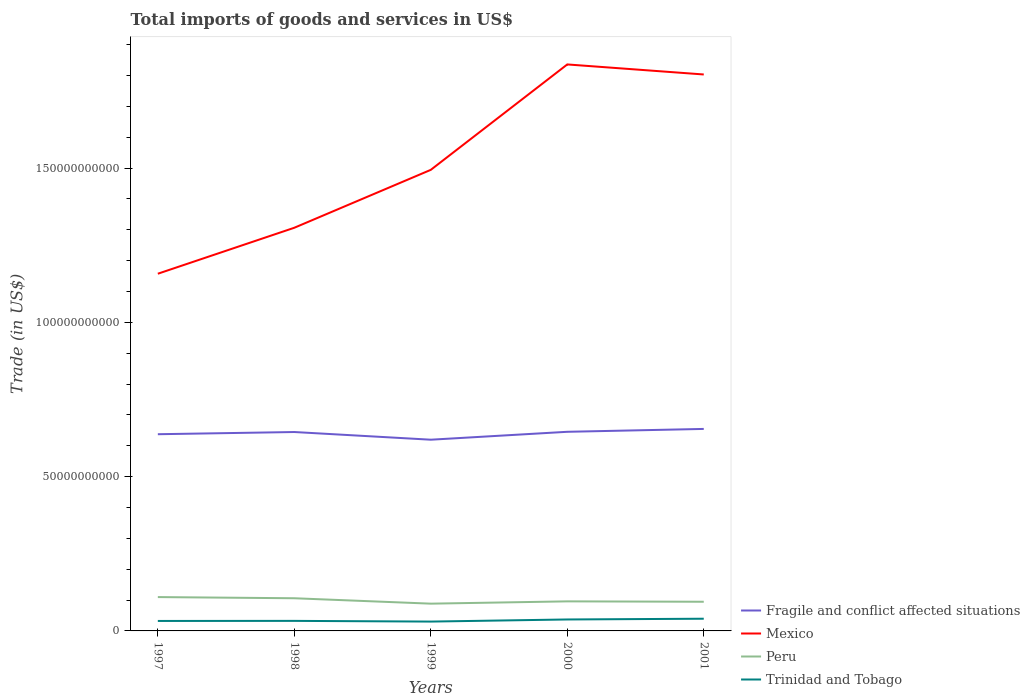Is the number of lines equal to the number of legend labels?
Your response must be concise. Yes. Across all years, what is the maximum total imports of goods and services in Mexico?
Make the answer very short. 1.16e+11. In which year was the total imports of goods and services in Peru maximum?
Ensure brevity in your answer.  1999. What is the total total imports of goods and services in Peru in the graph?
Provide a succinct answer. 3.81e+08. What is the difference between the highest and the second highest total imports of goods and services in Peru?
Make the answer very short. 2.13e+09. Is the total imports of goods and services in Fragile and conflict affected situations strictly greater than the total imports of goods and services in Peru over the years?
Give a very brief answer. No. What is the difference between two consecutive major ticks on the Y-axis?
Provide a succinct answer. 5.00e+1. How many legend labels are there?
Provide a short and direct response. 4. How are the legend labels stacked?
Keep it short and to the point. Vertical. What is the title of the graph?
Keep it short and to the point. Total imports of goods and services in US$. What is the label or title of the X-axis?
Your answer should be very brief. Years. What is the label or title of the Y-axis?
Provide a succinct answer. Trade (in US$). What is the Trade (in US$) of Fragile and conflict affected situations in 1997?
Your answer should be very brief. 6.37e+1. What is the Trade (in US$) in Mexico in 1997?
Make the answer very short. 1.16e+11. What is the Trade (in US$) of Peru in 1997?
Your answer should be compact. 1.10e+1. What is the Trade (in US$) in Trinidad and Tobago in 1997?
Offer a terse response. 3.23e+09. What is the Trade (in US$) of Fragile and conflict affected situations in 1998?
Offer a terse response. 6.45e+1. What is the Trade (in US$) of Mexico in 1998?
Your answer should be compact. 1.31e+11. What is the Trade (in US$) of Peru in 1998?
Your answer should be very brief. 1.06e+1. What is the Trade (in US$) of Trinidad and Tobago in 1998?
Offer a very short reply. 3.25e+09. What is the Trade (in US$) of Fragile and conflict affected situations in 1999?
Ensure brevity in your answer.  6.20e+1. What is the Trade (in US$) in Mexico in 1999?
Provide a succinct answer. 1.49e+11. What is the Trade (in US$) of Peru in 1999?
Keep it short and to the point. 8.84e+09. What is the Trade (in US$) of Trinidad and Tobago in 1999?
Give a very brief answer. 3.03e+09. What is the Trade (in US$) in Fragile and conflict affected situations in 2000?
Your answer should be very brief. 6.45e+1. What is the Trade (in US$) in Mexico in 2000?
Keep it short and to the point. 1.84e+11. What is the Trade (in US$) in Peru in 2000?
Ensure brevity in your answer.  9.58e+09. What is the Trade (in US$) of Trinidad and Tobago in 2000?
Your answer should be very brief. 3.71e+09. What is the Trade (in US$) in Fragile and conflict affected situations in 2001?
Provide a short and direct response. 6.55e+1. What is the Trade (in US$) of Mexico in 2001?
Offer a terse response. 1.80e+11. What is the Trade (in US$) of Peru in 2001?
Make the answer very short. 9.45e+09. What is the Trade (in US$) of Trinidad and Tobago in 2001?
Provide a short and direct response. 3.96e+09. Across all years, what is the maximum Trade (in US$) of Fragile and conflict affected situations?
Your response must be concise. 6.55e+1. Across all years, what is the maximum Trade (in US$) of Mexico?
Provide a short and direct response. 1.84e+11. Across all years, what is the maximum Trade (in US$) in Peru?
Keep it short and to the point. 1.10e+1. Across all years, what is the maximum Trade (in US$) of Trinidad and Tobago?
Your response must be concise. 3.96e+09. Across all years, what is the minimum Trade (in US$) in Fragile and conflict affected situations?
Make the answer very short. 6.20e+1. Across all years, what is the minimum Trade (in US$) of Mexico?
Offer a very short reply. 1.16e+11. Across all years, what is the minimum Trade (in US$) in Peru?
Your answer should be very brief. 8.84e+09. Across all years, what is the minimum Trade (in US$) of Trinidad and Tobago?
Give a very brief answer. 3.03e+09. What is the total Trade (in US$) in Fragile and conflict affected situations in the graph?
Your answer should be compact. 3.20e+11. What is the total Trade (in US$) of Mexico in the graph?
Provide a short and direct response. 7.60e+11. What is the total Trade (in US$) of Peru in the graph?
Provide a succinct answer. 4.94e+1. What is the total Trade (in US$) of Trinidad and Tobago in the graph?
Make the answer very short. 1.72e+1. What is the difference between the Trade (in US$) in Fragile and conflict affected situations in 1997 and that in 1998?
Make the answer very short. -7.10e+08. What is the difference between the Trade (in US$) in Mexico in 1997 and that in 1998?
Provide a short and direct response. -1.49e+1. What is the difference between the Trade (in US$) of Peru in 1997 and that in 1998?
Ensure brevity in your answer.  3.81e+08. What is the difference between the Trade (in US$) of Trinidad and Tobago in 1997 and that in 1998?
Your answer should be very brief. -2.36e+07. What is the difference between the Trade (in US$) of Fragile and conflict affected situations in 1997 and that in 1999?
Give a very brief answer. 1.78e+09. What is the difference between the Trade (in US$) of Mexico in 1997 and that in 1999?
Offer a terse response. -3.37e+1. What is the difference between the Trade (in US$) of Peru in 1997 and that in 1999?
Offer a terse response. 2.13e+09. What is the difference between the Trade (in US$) of Trinidad and Tobago in 1997 and that in 1999?
Keep it short and to the point. 2.04e+08. What is the difference between the Trade (in US$) in Fragile and conflict affected situations in 1997 and that in 2000?
Offer a terse response. -7.82e+08. What is the difference between the Trade (in US$) of Mexico in 1997 and that in 2000?
Make the answer very short. -6.78e+1. What is the difference between the Trade (in US$) of Peru in 1997 and that in 2000?
Provide a succinct answer. 1.39e+09. What is the difference between the Trade (in US$) in Trinidad and Tobago in 1997 and that in 2000?
Give a very brief answer. -4.79e+08. What is the difference between the Trade (in US$) of Fragile and conflict affected situations in 1997 and that in 2001?
Ensure brevity in your answer.  -1.72e+09. What is the difference between the Trade (in US$) of Mexico in 1997 and that in 2001?
Give a very brief answer. -6.46e+1. What is the difference between the Trade (in US$) of Peru in 1997 and that in 2001?
Your answer should be very brief. 1.51e+09. What is the difference between the Trade (in US$) in Trinidad and Tobago in 1997 and that in 2001?
Ensure brevity in your answer.  -7.26e+08. What is the difference between the Trade (in US$) of Fragile and conflict affected situations in 1998 and that in 1999?
Keep it short and to the point. 2.49e+09. What is the difference between the Trade (in US$) of Mexico in 1998 and that in 1999?
Provide a short and direct response. -1.88e+1. What is the difference between the Trade (in US$) in Peru in 1998 and that in 1999?
Offer a very short reply. 1.75e+09. What is the difference between the Trade (in US$) of Trinidad and Tobago in 1998 and that in 1999?
Your answer should be very brief. 2.28e+08. What is the difference between the Trade (in US$) of Fragile and conflict affected situations in 1998 and that in 2000?
Offer a terse response. -7.17e+07. What is the difference between the Trade (in US$) of Mexico in 1998 and that in 2000?
Give a very brief answer. -5.29e+1. What is the difference between the Trade (in US$) in Peru in 1998 and that in 2000?
Give a very brief answer. 1.01e+09. What is the difference between the Trade (in US$) of Trinidad and Tobago in 1998 and that in 2000?
Keep it short and to the point. -4.55e+08. What is the difference between the Trade (in US$) of Fragile and conflict affected situations in 1998 and that in 2001?
Provide a succinct answer. -1.01e+09. What is the difference between the Trade (in US$) in Mexico in 1998 and that in 2001?
Offer a terse response. -4.97e+1. What is the difference between the Trade (in US$) in Peru in 1998 and that in 2001?
Your answer should be very brief. 1.13e+09. What is the difference between the Trade (in US$) of Trinidad and Tobago in 1998 and that in 2001?
Your response must be concise. -7.02e+08. What is the difference between the Trade (in US$) in Fragile and conflict affected situations in 1999 and that in 2000?
Your answer should be very brief. -2.56e+09. What is the difference between the Trade (in US$) in Mexico in 1999 and that in 2000?
Your response must be concise. -3.42e+1. What is the difference between the Trade (in US$) of Peru in 1999 and that in 2000?
Offer a terse response. -7.44e+08. What is the difference between the Trade (in US$) in Trinidad and Tobago in 1999 and that in 2000?
Your response must be concise. -6.83e+08. What is the difference between the Trade (in US$) of Fragile and conflict affected situations in 1999 and that in 2001?
Ensure brevity in your answer.  -3.50e+09. What is the difference between the Trade (in US$) in Mexico in 1999 and that in 2001?
Your answer should be very brief. -3.09e+1. What is the difference between the Trade (in US$) in Peru in 1999 and that in 2001?
Ensure brevity in your answer.  -6.18e+08. What is the difference between the Trade (in US$) in Trinidad and Tobago in 1999 and that in 2001?
Give a very brief answer. -9.30e+08. What is the difference between the Trade (in US$) in Fragile and conflict affected situations in 2000 and that in 2001?
Ensure brevity in your answer.  -9.34e+08. What is the difference between the Trade (in US$) of Mexico in 2000 and that in 2001?
Provide a short and direct response. 3.25e+09. What is the difference between the Trade (in US$) of Peru in 2000 and that in 2001?
Offer a very short reply. 1.26e+08. What is the difference between the Trade (in US$) of Trinidad and Tobago in 2000 and that in 2001?
Provide a succinct answer. -2.47e+08. What is the difference between the Trade (in US$) in Fragile and conflict affected situations in 1997 and the Trade (in US$) in Mexico in 1998?
Provide a succinct answer. -6.69e+1. What is the difference between the Trade (in US$) of Fragile and conflict affected situations in 1997 and the Trade (in US$) of Peru in 1998?
Provide a succinct answer. 5.32e+1. What is the difference between the Trade (in US$) of Fragile and conflict affected situations in 1997 and the Trade (in US$) of Trinidad and Tobago in 1998?
Your answer should be very brief. 6.05e+1. What is the difference between the Trade (in US$) in Mexico in 1997 and the Trade (in US$) in Peru in 1998?
Provide a succinct answer. 1.05e+11. What is the difference between the Trade (in US$) in Mexico in 1997 and the Trade (in US$) in Trinidad and Tobago in 1998?
Provide a short and direct response. 1.13e+11. What is the difference between the Trade (in US$) in Peru in 1997 and the Trade (in US$) in Trinidad and Tobago in 1998?
Make the answer very short. 7.71e+09. What is the difference between the Trade (in US$) of Fragile and conflict affected situations in 1997 and the Trade (in US$) of Mexico in 1999?
Offer a terse response. -8.57e+1. What is the difference between the Trade (in US$) in Fragile and conflict affected situations in 1997 and the Trade (in US$) in Peru in 1999?
Give a very brief answer. 5.49e+1. What is the difference between the Trade (in US$) in Fragile and conflict affected situations in 1997 and the Trade (in US$) in Trinidad and Tobago in 1999?
Provide a succinct answer. 6.07e+1. What is the difference between the Trade (in US$) of Mexico in 1997 and the Trade (in US$) of Peru in 1999?
Provide a short and direct response. 1.07e+11. What is the difference between the Trade (in US$) in Mexico in 1997 and the Trade (in US$) in Trinidad and Tobago in 1999?
Make the answer very short. 1.13e+11. What is the difference between the Trade (in US$) of Peru in 1997 and the Trade (in US$) of Trinidad and Tobago in 1999?
Offer a very short reply. 7.94e+09. What is the difference between the Trade (in US$) of Fragile and conflict affected situations in 1997 and the Trade (in US$) of Mexico in 2000?
Make the answer very short. -1.20e+11. What is the difference between the Trade (in US$) of Fragile and conflict affected situations in 1997 and the Trade (in US$) of Peru in 2000?
Provide a short and direct response. 5.42e+1. What is the difference between the Trade (in US$) of Fragile and conflict affected situations in 1997 and the Trade (in US$) of Trinidad and Tobago in 2000?
Your answer should be compact. 6.00e+1. What is the difference between the Trade (in US$) of Mexico in 1997 and the Trade (in US$) of Peru in 2000?
Provide a succinct answer. 1.06e+11. What is the difference between the Trade (in US$) in Mexico in 1997 and the Trade (in US$) in Trinidad and Tobago in 2000?
Offer a terse response. 1.12e+11. What is the difference between the Trade (in US$) of Peru in 1997 and the Trade (in US$) of Trinidad and Tobago in 2000?
Offer a very short reply. 7.26e+09. What is the difference between the Trade (in US$) in Fragile and conflict affected situations in 1997 and the Trade (in US$) in Mexico in 2001?
Provide a succinct answer. -1.17e+11. What is the difference between the Trade (in US$) of Fragile and conflict affected situations in 1997 and the Trade (in US$) of Peru in 2001?
Your answer should be compact. 5.43e+1. What is the difference between the Trade (in US$) in Fragile and conflict affected situations in 1997 and the Trade (in US$) in Trinidad and Tobago in 2001?
Provide a short and direct response. 5.98e+1. What is the difference between the Trade (in US$) in Mexico in 1997 and the Trade (in US$) in Peru in 2001?
Your response must be concise. 1.06e+11. What is the difference between the Trade (in US$) in Mexico in 1997 and the Trade (in US$) in Trinidad and Tobago in 2001?
Your answer should be very brief. 1.12e+11. What is the difference between the Trade (in US$) in Peru in 1997 and the Trade (in US$) in Trinidad and Tobago in 2001?
Provide a succinct answer. 7.01e+09. What is the difference between the Trade (in US$) in Fragile and conflict affected situations in 1998 and the Trade (in US$) in Mexico in 1999?
Offer a very short reply. -8.50e+1. What is the difference between the Trade (in US$) in Fragile and conflict affected situations in 1998 and the Trade (in US$) in Peru in 1999?
Offer a terse response. 5.56e+1. What is the difference between the Trade (in US$) of Fragile and conflict affected situations in 1998 and the Trade (in US$) of Trinidad and Tobago in 1999?
Your answer should be very brief. 6.14e+1. What is the difference between the Trade (in US$) of Mexico in 1998 and the Trade (in US$) of Peru in 1999?
Your answer should be compact. 1.22e+11. What is the difference between the Trade (in US$) in Mexico in 1998 and the Trade (in US$) in Trinidad and Tobago in 1999?
Keep it short and to the point. 1.28e+11. What is the difference between the Trade (in US$) in Peru in 1998 and the Trade (in US$) in Trinidad and Tobago in 1999?
Offer a very short reply. 7.56e+09. What is the difference between the Trade (in US$) in Fragile and conflict affected situations in 1998 and the Trade (in US$) in Mexico in 2000?
Your answer should be very brief. -1.19e+11. What is the difference between the Trade (in US$) in Fragile and conflict affected situations in 1998 and the Trade (in US$) in Peru in 2000?
Offer a terse response. 5.49e+1. What is the difference between the Trade (in US$) of Fragile and conflict affected situations in 1998 and the Trade (in US$) of Trinidad and Tobago in 2000?
Your response must be concise. 6.07e+1. What is the difference between the Trade (in US$) of Mexico in 1998 and the Trade (in US$) of Peru in 2000?
Offer a very short reply. 1.21e+11. What is the difference between the Trade (in US$) in Mexico in 1998 and the Trade (in US$) in Trinidad and Tobago in 2000?
Give a very brief answer. 1.27e+11. What is the difference between the Trade (in US$) of Peru in 1998 and the Trade (in US$) of Trinidad and Tobago in 2000?
Offer a terse response. 6.88e+09. What is the difference between the Trade (in US$) in Fragile and conflict affected situations in 1998 and the Trade (in US$) in Mexico in 2001?
Ensure brevity in your answer.  -1.16e+11. What is the difference between the Trade (in US$) of Fragile and conflict affected situations in 1998 and the Trade (in US$) of Peru in 2001?
Your response must be concise. 5.50e+1. What is the difference between the Trade (in US$) in Fragile and conflict affected situations in 1998 and the Trade (in US$) in Trinidad and Tobago in 2001?
Offer a terse response. 6.05e+1. What is the difference between the Trade (in US$) of Mexico in 1998 and the Trade (in US$) of Peru in 2001?
Your answer should be compact. 1.21e+11. What is the difference between the Trade (in US$) in Mexico in 1998 and the Trade (in US$) in Trinidad and Tobago in 2001?
Keep it short and to the point. 1.27e+11. What is the difference between the Trade (in US$) of Peru in 1998 and the Trade (in US$) of Trinidad and Tobago in 2001?
Provide a short and direct response. 6.63e+09. What is the difference between the Trade (in US$) of Fragile and conflict affected situations in 1999 and the Trade (in US$) of Mexico in 2000?
Ensure brevity in your answer.  -1.22e+11. What is the difference between the Trade (in US$) in Fragile and conflict affected situations in 1999 and the Trade (in US$) in Peru in 2000?
Provide a short and direct response. 5.24e+1. What is the difference between the Trade (in US$) in Fragile and conflict affected situations in 1999 and the Trade (in US$) in Trinidad and Tobago in 2000?
Your answer should be very brief. 5.83e+1. What is the difference between the Trade (in US$) in Mexico in 1999 and the Trade (in US$) in Peru in 2000?
Ensure brevity in your answer.  1.40e+11. What is the difference between the Trade (in US$) in Mexico in 1999 and the Trade (in US$) in Trinidad and Tobago in 2000?
Provide a succinct answer. 1.46e+11. What is the difference between the Trade (in US$) of Peru in 1999 and the Trade (in US$) of Trinidad and Tobago in 2000?
Your answer should be very brief. 5.13e+09. What is the difference between the Trade (in US$) of Fragile and conflict affected situations in 1999 and the Trade (in US$) of Mexico in 2001?
Make the answer very short. -1.18e+11. What is the difference between the Trade (in US$) of Fragile and conflict affected situations in 1999 and the Trade (in US$) of Peru in 2001?
Make the answer very short. 5.25e+1. What is the difference between the Trade (in US$) of Fragile and conflict affected situations in 1999 and the Trade (in US$) of Trinidad and Tobago in 2001?
Ensure brevity in your answer.  5.80e+1. What is the difference between the Trade (in US$) in Mexico in 1999 and the Trade (in US$) in Peru in 2001?
Make the answer very short. 1.40e+11. What is the difference between the Trade (in US$) in Mexico in 1999 and the Trade (in US$) in Trinidad and Tobago in 2001?
Your answer should be compact. 1.45e+11. What is the difference between the Trade (in US$) of Peru in 1999 and the Trade (in US$) of Trinidad and Tobago in 2001?
Provide a short and direct response. 4.88e+09. What is the difference between the Trade (in US$) in Fragile and conflict affected situations in 2000 and the Trade (in US$) in Mexico in 2001?
Your answer should be compact. -1.16e+11. What is the difference between the Trade (in US$) of Fragile and conflict affected situations in 2000 and the Trade (in US$) of Peru in 2001?
Your response must be concise. 5.51e+1. What is the difference between the Trade (in US$) in Fragile and conflict affected situations in 2000 and the Trade (in US$) in Trinidad and Tobago in 2001?
Ensure brevity in your answer.  6.06e+1. What is the difference between the Trade (in US$) of Mexico in 2000 and the Trade (in US$) of Peru in 2001?
Provide a succinct answer. 1.74e+11. What is the difference between the Trade (in US$) in Mexico in 2000 and the Trade (in US$) in Trinidad and Tobago in 2001?
Offer a terse response. 1.80e+11. What is the difference between the Trade (in US$) in Peru in 2000 and the Trade (in US$) in Trinidad and Tobago in 2001?
Your answer should be compact. 5.62e+09. What is the average Trade (in US$) of Fragile and conflict affected situations per year?
Give a very brief answer. 6.40e+1. What is the average Trade (in US$) in Mexico per year?
Offer a terse response. 1.52e+11. What is the average Trade (in US$) in Peru per year?
Keep it short and to the point. 9.89e+09. What is the average Trade (in US$) of Trinidad and Tobago per year?
Offer a very short reply. 3.44e+09. In the year 1997, what is the difference between the Trade (in US$) in Fragile and conflict affected situations and Trade (in US$) in Mexico?
Make the answer very short. -5.20e+1. In the year 1997, what is the difference between the Trade (in US$) of Fragile and conflict affected situations and Trade (in US$) of Peru?
Give a very brief answer. 5.28e+1. In the year 1997, what is the difference between the Trade (in US$) of Fragile and conflict affected situations and Trade (in US$) of Trinidad and Tobago?
Provide a succinct answer. 6.05e+1. In the year 1997, what is the difference between the Trade (in US$) in Mexico and Trade (in US$) in Peru?
Give a very brief answer. 1.05e+11. In the year 1997, what is the difference between the Trade (in US$) in Mexico and Trade (in US$) in Trinidad and Tobago?
Keep it short and to the point. 1.13e+11. In the year 1997, what is the difference between the Trade (in US$) in Peru and Trade (in US$) in Trinidad and Tobago?
Ensure brevity in your answer.  7.74e+09. In the year 1998, what is the difference between the Trade (in US$) in Fragile and conflict affected situations and Trade (in US$) in Mexico?
Keep it short and to the point. -6.62e+1. In the year 1998, what is the difference between the Trade (in US$) of Fragile and conflict affected situations and Trade (in US$) of Peru?
Your response must be concise. 5.39e+1. In the year 1998, what is the difference between the Trade (in US$) in Fragile and conflict affected situations and Trade (in US$) in Trinidad and Tobago?
Offer a very short reply. 6.12e+1. In the year 1998, what is the difference between the Trade (in US$) of Mexico and Trade (in US$) of Peru?
Your response must be concise. 1.20e+11. In the year 1998, what is the difference between the Trade (in US$) in Mexico and Trade (in US$) in Trinidad and Tobago?
Your response must be concise. 1.27e+11. In the year 1998, what is the difference between the Trade (in US$) of Peru and Trade (in US$) of Trinidad and Tobago?
Make the answer very short. 7.33e+09. In the year 1999, what is the difference between the Trade (in US$) of Fragile and conflict affected situations and Trade (in US$) of Mexico?
Offer a very short reply. -8.75e+1. In the year 1999, what is the difference between the Trade (in US$) of Fragile and conflict affected situations and Trade (in US$) of Peru?
Offer a very short reply. 5.31e+1. In the year 1999, what is the difference between the Trade (in US$) of Fragile and conflict affected situations and Trade (in US$) of Trinidad and Tobago?
Provide a succinct answer. 5.89e+1. In the year 1999, what is the difference between the Trade (in US$) in Mexico and Trade (in US$) in Peru?
Provide a succinct answer. 1.41e+11. In the year 1999, what is the difference between the Trade (in US$) in Mexico and Trade (in US$) in Trinidad and Tobago?
Your response must be concise. 1.46e+11. In the year 1999, what is the difference between the Trade (in US$) of Peru and Trade (in US$) of Trinidad and Tobago?
Your answer should be compact. 5.81e+09. In the year 2000, what is the difference between the Trade (in US$) in Fragile and conflict affected situations and Trade (in US$) in Mexico?
Give a very brief answer. -1.19e+11. In the year 2000, what is the difference between the Trade (in US$) in Fragile and conflict affected situations and Trade (in US$) in Peru?
Offer a very short reply. 5.50e+1. In the year 2000, what is the difference between the Trade (in US$) in Fragile and conflict affected situations and Trade (in US$) in Trinidad and Tobago?
Your answer should be very brief. 6.08e+1. In the year 2000, what is the difference between the Trade (in US$) in Mexico and Trade (in US$) in Peru?
Provide a succinct answer. 1.74e+11. In the year 2000, what is the difference between the Trade (in US$) of Mexico and Trade (in US$) of Trinidad and Tobago?
Your answer should be very brief. 1.80e+11. In the year 2000, what is the difference between the Trade (in US$) of Peru and Trade (in US$) of Trinidad and Tobago?
Give a very brief answer. 5.87e+09. In the year 2001, what is the difference between the Trade (in US$) of Fragile and conflict affected situations and Trade (in US$) of Mexico?
Give a very brief answer. -1.15e+11. In the year 2001, what is the difference between the Trade (in US$) in Fragile and conflict affected situations and Trade (in US$) in Peru?
Your answer should be compact. 5.60e+1. In the year 2001, what is the difference between the Trade (in US$) of Fragile and conflict affected situations and Trade (in US$) of Trinidad and Tobago?
Give a very brief answer. 6.15e+1. In the year 2001, what is the difference between the Trade (in US$) in Mexico and Trade (in US$) in Peru?
Your answer should be very brief. 1.71e+11. In the year 2001, what is the difference between the Trade (in US$) in Mexico and Trade (in US$) in Trinidad and Tobago?
Make the answer very short. 1.76e+11. In the year 2001, what is the difference between the Trade (in US$) of Peru and Trade (in US$) of Trinidad and Tobago?
Offer a terse response. 5.50e+09. What is the ratio of the Trade (in US$) in Fragile and conflict affected situations in 1997 to that in 1998?
Your answer should be very brief. 0.99. What is the ratio of the Trade (in US$) in Mexico in 1997 to that in 1998?
Offer a very short reply. 0.89. What is the ratio of the Trade (in US$) in Peru in 1997 to that in 1998?
Keep it short and to the point. 1.04. What is the ratio of the Trade (in US$) in Trinidad and Tobago in 1997 to that in 1998?
Ensure brevity in your answer.  0.99. What is the ratio of the Trade (in US$) in Fragile and conflict affected situations in 1997 to that in 1999?
Provide a short and direct response. 1.03. What is the ratio of the Trade (in US$) of Mexico in 1997 to that in 1999?
Keep it short and to the point. 0.77. What is the ratio of the Trade (in US$) of Peru in 1997 to that in 1999?
Keep it short and to the point. 1.24. What is the ratio of the Trade (in US$) in Trinidad and Tobago in 1997 to that in 1999?
Your response must be concise. 1.07. What is the ratio of the Trade (in US$) in Fragile and conflict affected situations in 1997 to that in 2000?
Offer a very short reply. 0.99. What is the ratio of the Trade (in US$) of Mexico in 1997 to that in 2000?
Offer a very short reply. 0.63. What is the ratio of the Trade (in US$) in Peru in 1997 to that in 2000?
Your answer should be very brief. 1.14. What is the ratio of the Trade (in US$) in Trinidad and Tobago in 1997 to that in 2000?
Keep it short and to the point. 0.87. What is the ratio of the Trade (in US$) of Fragile and conflict affected situations in 1997 to that in 2001?
Offer a terse response. 0.97. What is the ratio of the Trade (in US$) in Mexico in 1997 to that in 2001?
Offer a terse response. 0.64. What is the ratio of the Trade (in US$) in Peru in 1997 to that in 2001?
Your response must be concise. 1.16. What is the ratio of the Trade (in US$) of Trinidad and Tobago in 1997 to that in 2001?
Make the answer very short. 0.82. What is the ratio of the Trade (in US$) of Fragile and conflict affected situations in 1998 to that in 1999?
Ensure brevity in your answer.  1.04. What is the ratio of the Trade (in US$) of Mexico in 1998 to that in 1999?
Ensure brevity in your answer.  0.87. What is the ratio of the Trade (in US$) of Peru in 1998 to that in 1999?
Your response must be concise. 1.2. What is the ratio of the Trade (in US$) in Trinidad and Tobago in 1998 to that in 1999?
Your answer should be very brief. 1.08. What is the ratio of the Trade (in US$) of Mexico in 1998 to that in 2000?
Provide a short and direct response. 0.71. What is the ratio of the Trade (in US$) in Peru in 1998 to that in 2000?
Offer a very short reply. 1.11. What is the ratio of the Trade (in US$) of Trinidad and Tobago in 1998 to that in 2000?
Offer a very short reply. 0.88. What is the ratio of the Trade (in US$) in Fragile and conflict affected situations in 1998 to that in 2001?
Make the answer very short. 0.98. What is the ratio of the Trade (in US$) of Mexico in 1998 to that in 2001?
Your answer should be compact. 0.72. What is the ratio of the Trade (in US$) in Peru in 1998 to that in 2001?
Keep it short and to the point. 1.12. What is the ratio of the Trade (in US$) of Trinidad and Tobago in 1998 to that in 2001?
Your response must be concise. 0.82. What is the ratio of the Trade (in US$) in Fragile and conflict affected situations in 1999 to that in 2000?
Keep it short and to the point. 0.96. What is the ratio of the Trade (in US$) of Mexico in 1999 to that in 2000?
Your response must be concise. 0.81. What is the ratio of the Trade (in US$) in Peru in 1999 to that in 2000?
Offer a very short reply. 0.92. What is the ratio of the Trade (in US$) of Trinidad and Tobago in 1999 to that in 2000?
Provide a succinct answer. 0.82. What is the ratio of the Trade (in US$) in Fragile and conflict affected situations in 1999 to that in 2001?
Offer a very short reply. 0.95. What is the ratio of the Trade (in US$) of Mexico in 1999 to that in 2001?
Ensure brevity in your answer.  0.83. What is the ratio of the Trade (in US$) of Peru in 1999 to that in 2001?
Offer a very short reply. 0.93. What is the ratio of the Trade (in US$) of Trinidad and Tobago in 1999 to that in 2001?
Your response must be concise. 0.77. What is the ratio of the Trade (in US$) of Fragile and conflict affected situations in 2000 to that in 2001?
Provide a succinct answer. 0.99. What is the ratio of the Trade (in US$) of Peru in 2000 to that in 2001?
Keep it short and to the point. 1.01. What is the difference between the highest and the second highest Trade (in US$) of Fragile and conflict affected situations?
Your answer should be compact. 9.34e+08. What is the difference between the highest and the second highest Trade (in US$) in Mexico?
Keep it short and to the point. 3.25e+09. What is the difference between the highest and the second highest Trade (in US$) of Peru?
Provide a short and direct response. 3.81e+08. What is the difference between the highest and the second highest Trade (in US$) of Trinidad and Tobago?
Ensure brevity in your answer.  2.47e+08. What is the difference between the highest and the lowest Trade (in US$) in Fragile and conflict affected situations?
Provide a succinct answer. 3.50e+09. What is the difference between the highest and the lowest Trade (in US$) of Mexico?
Your answer should be compact. 6.78e+1. What is the difference between the highest and the lowest Trade (in US$) of Peru?
Give a very brief answer. 2.13e+09. What is the difference between the highest and the lowest Trade (in US$) in Trinidad and Tobago?
Make the answer very short. 9.30e+08. 